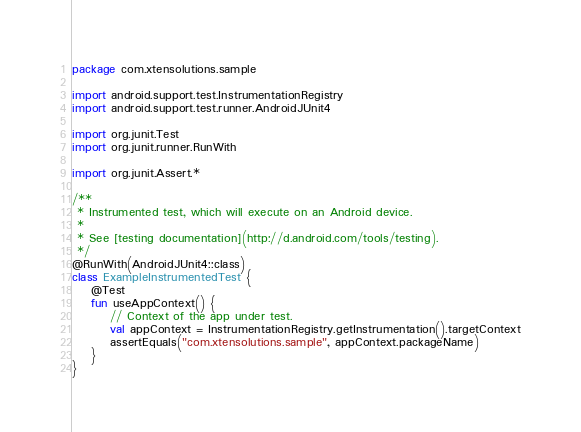Convert code to text. <code><loc_0><loc_0><loc_500><loc_500><_Kotlin_>package com.xtensolutions.sample

import android.support.test.InstrumentationRegistry
import android.support.test.runner.AndroidJUnit4

import org.junit.Test
import org.junit.runner.RunWith

import org.junit.Assert.*

/**
 * Instrumented test, which will execute on an Android device.
 *
 * See [testing documentation](http://d.android.com/tools/testing).
 */
@RunWith(AndroidJUnit4::class)
class ExampleInstrumentedTest {
    @Test
    fun useAppContext() {
        // Context of the app under test.
        val appContext = InstrumentationRegistry.getInstrumentation().targetContext
        assertEquals("com.xtensolutions.sample", appContext.packageName)
    }
}</code> 